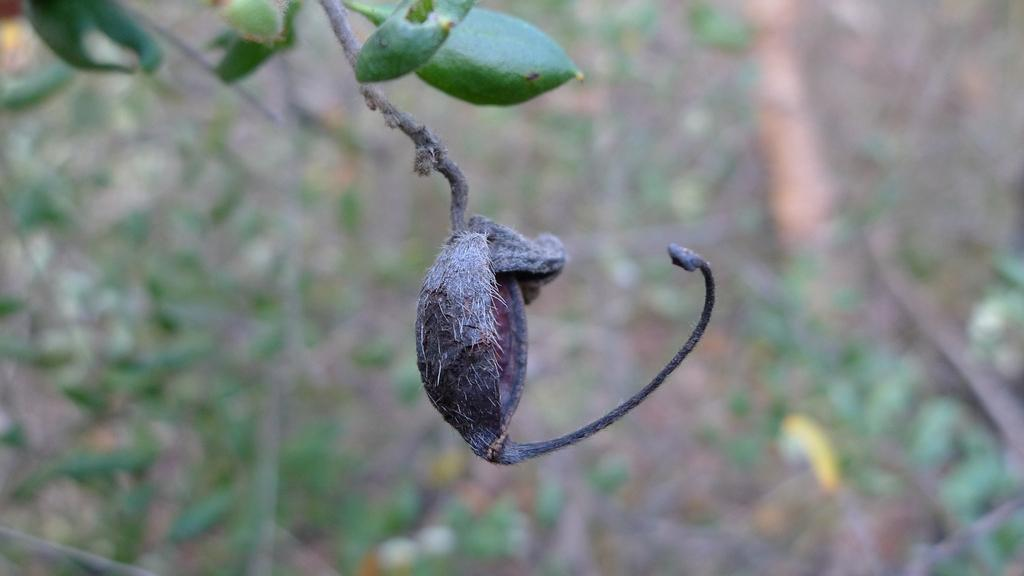What type of food is visible in the image? There is a dried fruit in the image. Where is the dried fruit located? The dried fruit is on a branch of a tree. How is the background of the branch depicted in the image? The background of the branch is blurred. What type of cap is the parent wearing in the image? There is no parent or cap present in the image; it features a dried fruit on a branch with a blurred background. 